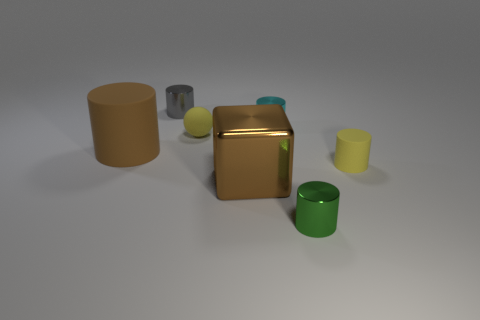There is a green object that is the same size as the yellow cylinder; what is it made of?
Your response must be concise. Metal. Is the number of tiny gray cylinders greater than the number of brown rubber spheres?
Make the answer very short. Yes. How big is the brown thing to the left of the small shiny object that is to the left of the small cyan cylinder?
Give a very brief answer. Large. The cyan object that is the same size as the green shiny cylinder is what shape?
Your response must be concise. Cylinder. There is a tiny yellow object right of the small shiny cylinder right of the cyan thing that is to the left of the green thing; what shape is it?
Ensure brevity in your answer.  Cylinder. There is a small thing on the left side of the yellow ball; is it the same color as the small rubber object on the right side of the small sphere?
Ensure brevity in your answer.  No. What number of small green things are there?
Give a very brief answer. 1. Are there any small yellow matte things on the right side of the small gray object?
Your answer should be compact. Yes. Are the large object that is left of the tiny ball and the large thing that is in front of the large brown matte cylinder made of the same material?
Make the answer very short. No. Is the number of brown cubes that are to the right of the metal block less than the number of big yellow matte balls?
Offer a terse response. No. 